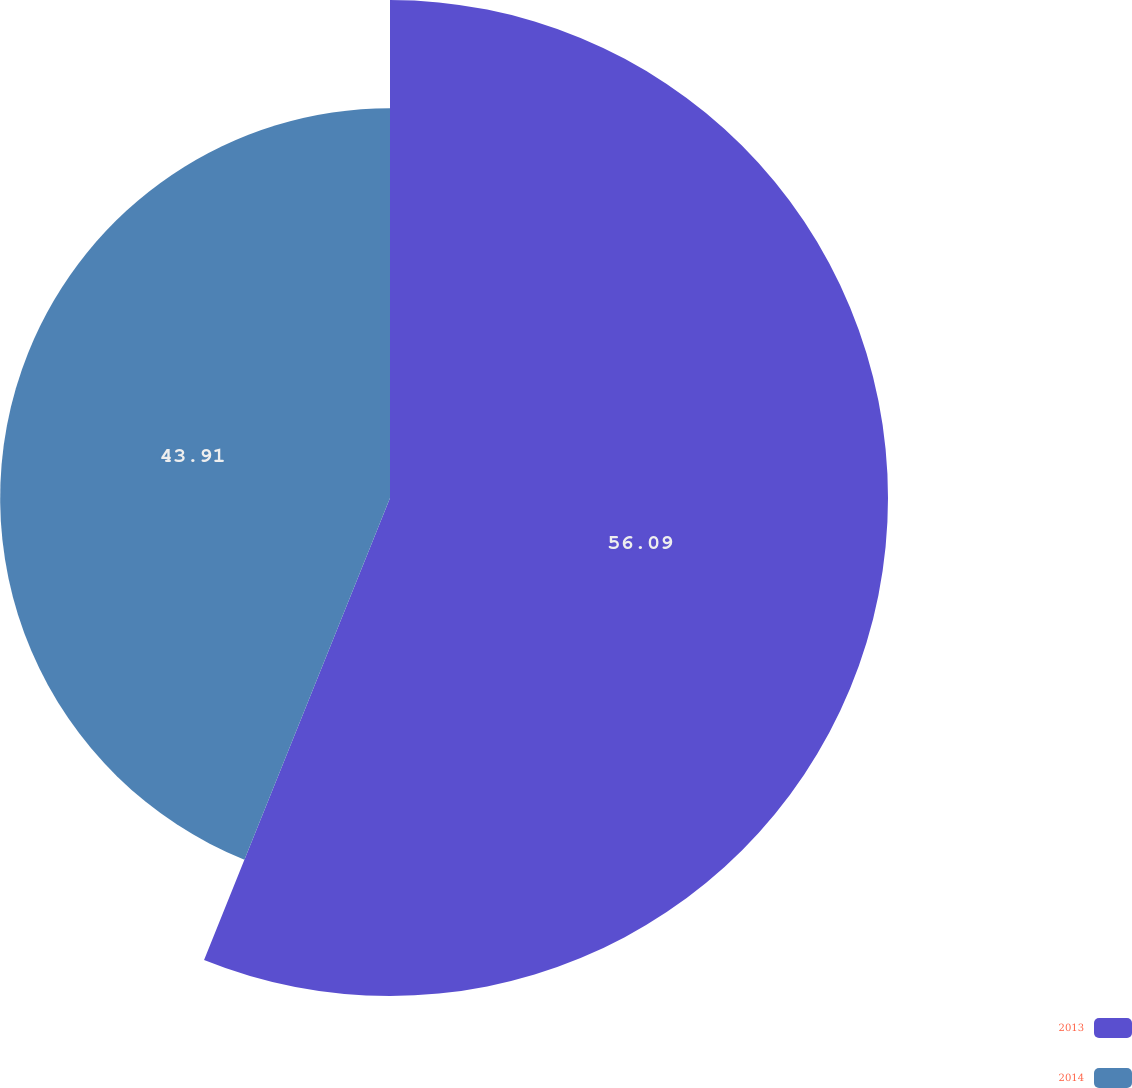<chart> <loc_0><loc_0><loc_500><loc_500><pie_chart><fcel>2013<fcel>2014<nl><fcel>56.09%<fcel>43.91%<nl></chart> 